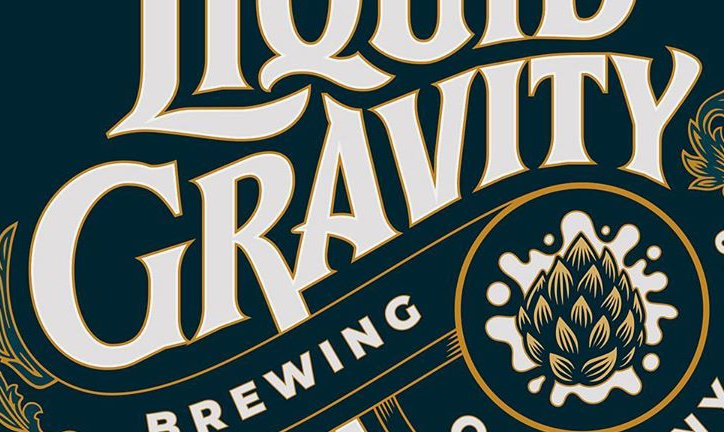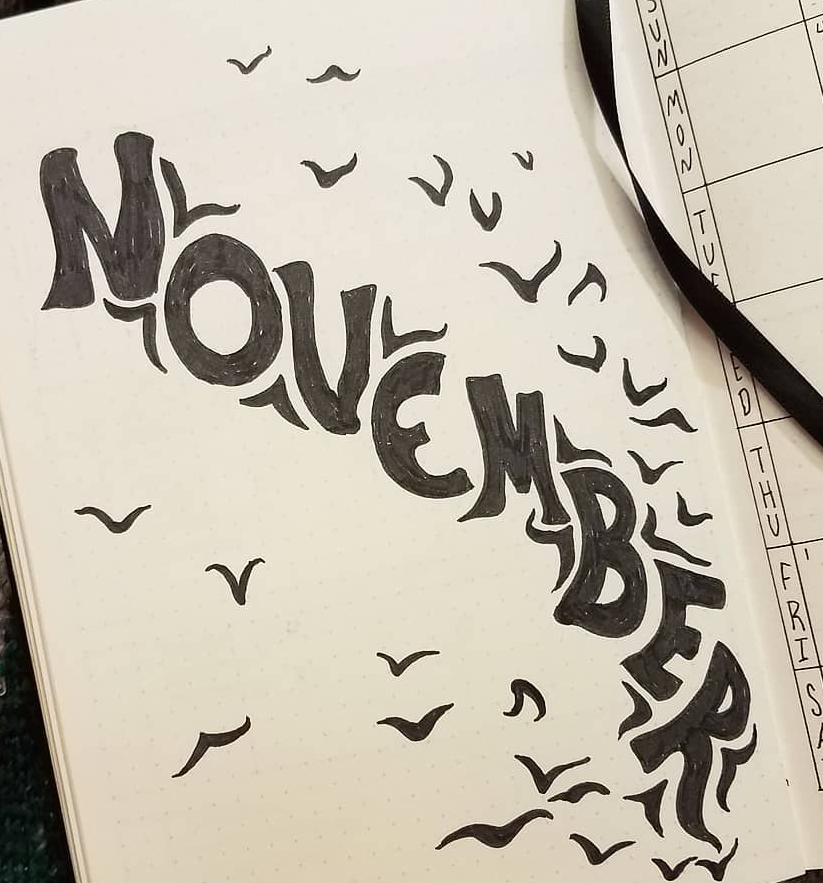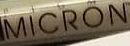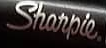Transcribe the words shown in these images in order, separated by a semicolon. GRAVITY; NOVEMBER; MICRON; Sharpie. 